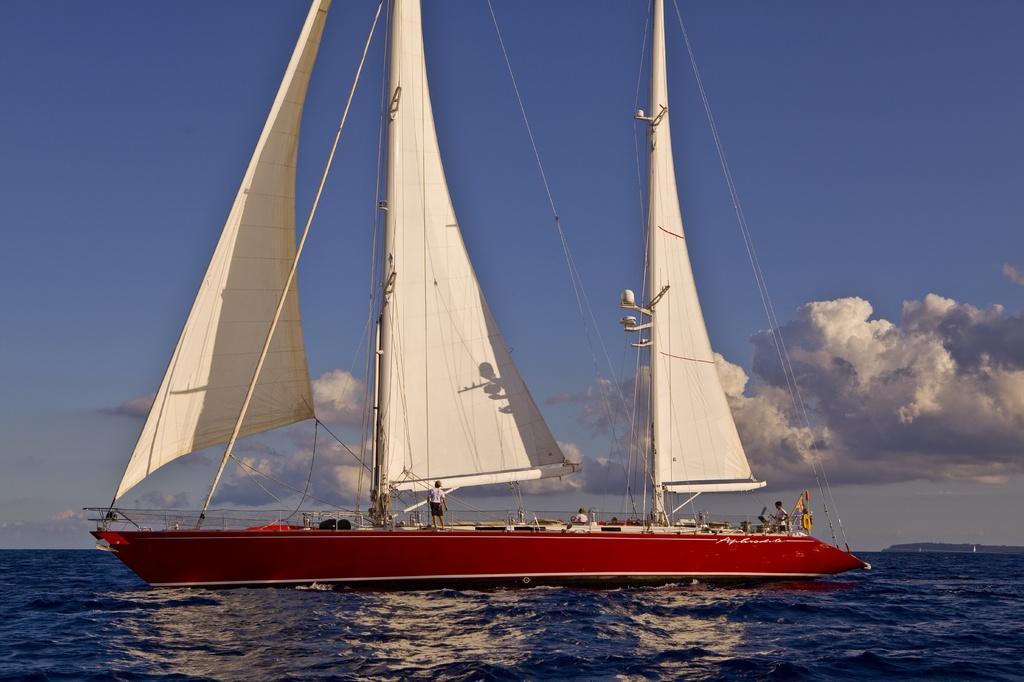Could you give a brief overview of what you see in this image? In this image there is the water. There is a boat on the water. There are a few people on the boat. At the top there is the sky. 